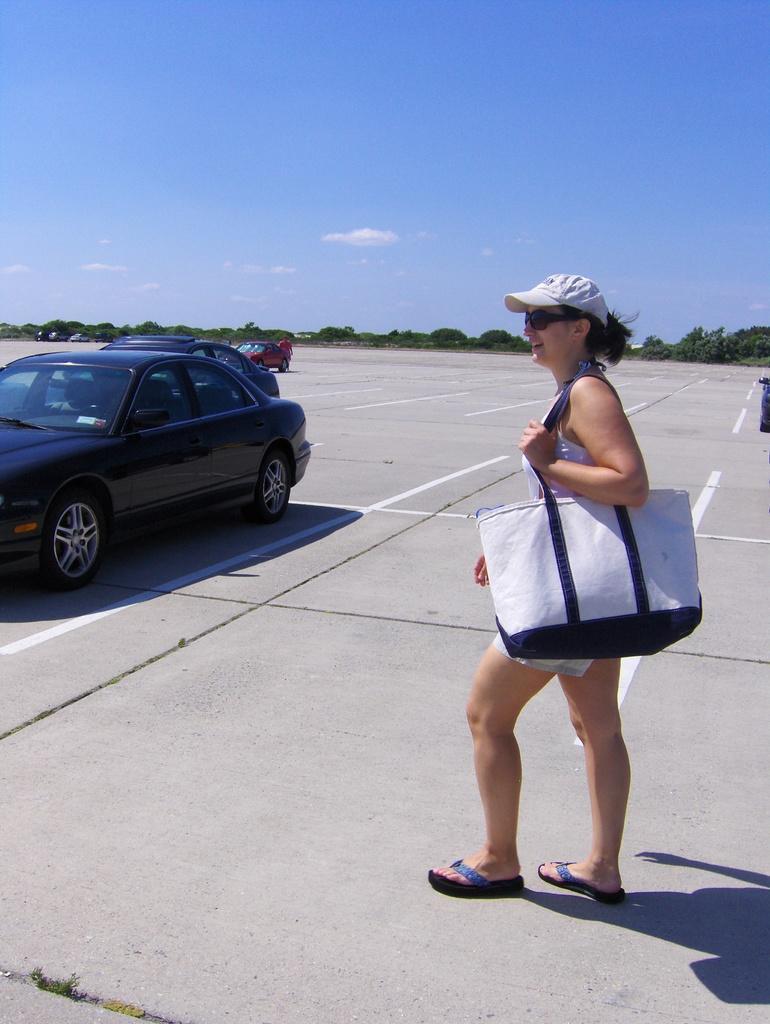In one or two sentences, can you explain what this image depicts? This woman wore cap, bag and walking, as there is a movement in her legs. Vehicles on road. Far there are number of trees. Sky is in blue color. 